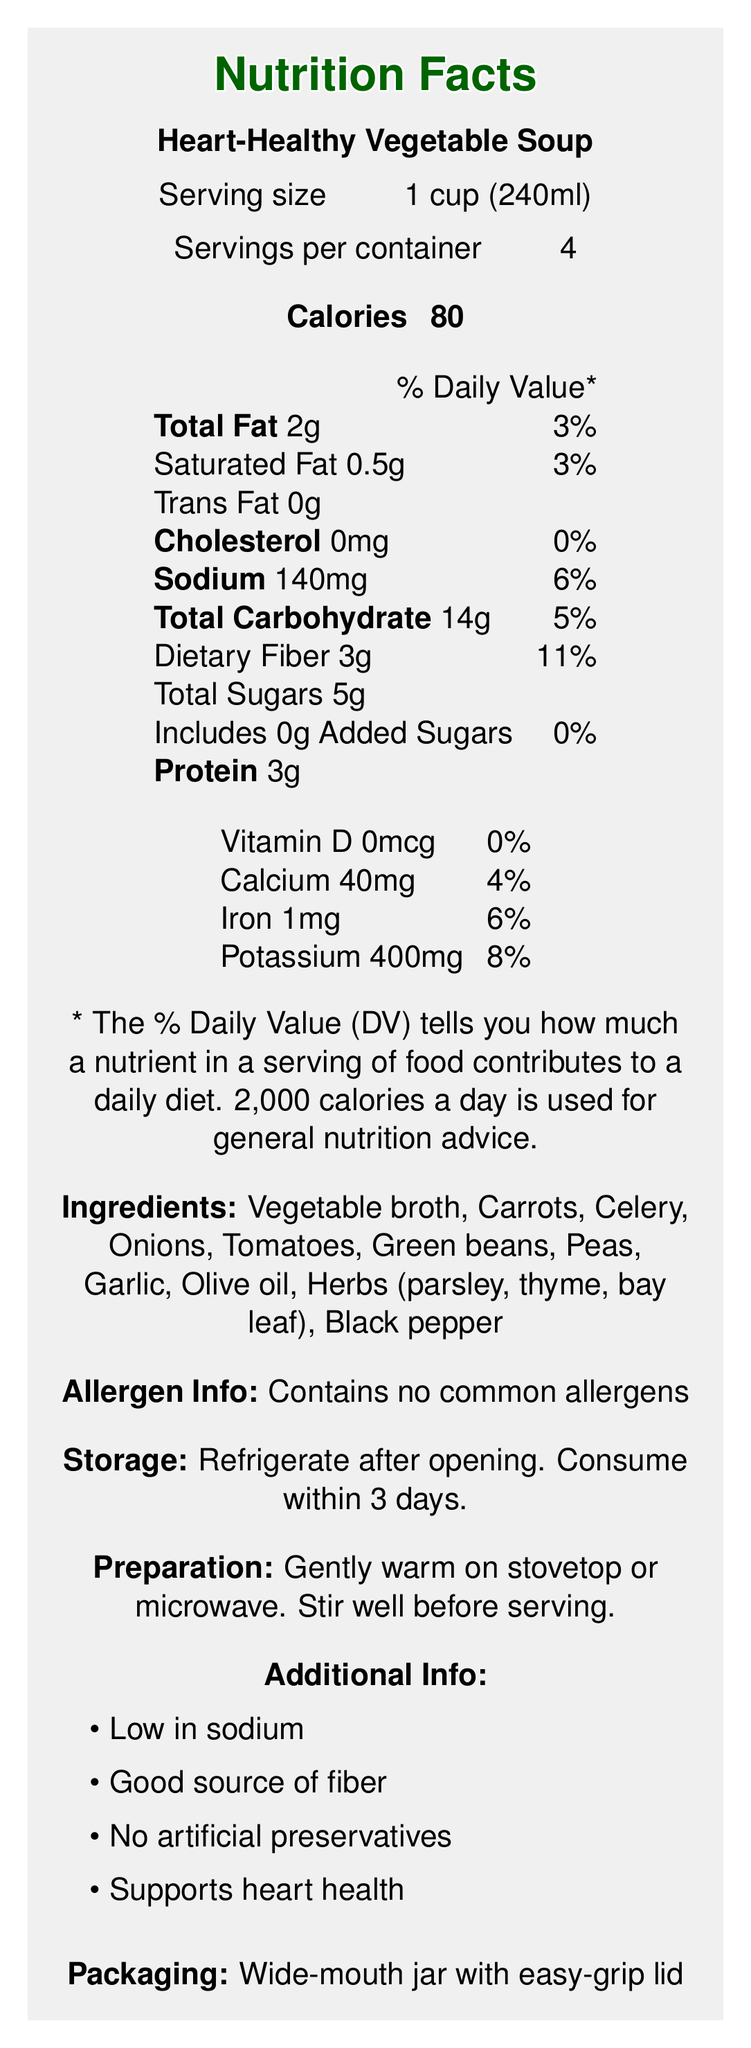what is the product name? The product name is clearly mentioned at the top of the Nutrition Facts Label as "Heart-Healthy Vegetable Soup."
Answer: Heart-Healthy Vegetable Soup what is the serving size? The serving size is specified right below the product name, "Serving size 1 cup (240ml)."
Answer: 1 cup (240ml) how many calories are in one serving of this soup? The number of calories per serving is listed as "Calories 80" in the document.
Answer: 80 what percentage of daily value is the sodium content per serving? The % Daily Value for sodium is indicated as "Sodium 140mg 6%" on the label.
Answer: 6% how many grams of dietary fiber are in a serving of this soup? The label specifies "Dietary Fiber 3g" under the total carbohydrate section.
Answer: 3g what vitamins and minerals are listed with their daily values? The vitamins and minerals along with their daily values are listed as "Vitamin D 0mcg 0%, Calcium 40mg 4%, Iron 1mg 6%, Potassium 400mg 8%."
Answer: Vitamin D, Calcium, Iron, Potassium what are the total servings per container? The number of servings per container is specified as "Servings per container 4."
Answer: 4 which ingredients are specified in the soup? A. Chicken broth, Carrots, Celery B. Vegetable broth, Carrots, Celery C. Beef broth, Carrots, Celery The ingredients are described as "Vegetable broth, Carrots, Celery" along with other vegetables and herbs.
Answer: B what is the cholesterol content per serving? The label indicates the cholesterol content as "Cholesterol 0mg 0%" under the fat content section.
Answer: 0mg is this soup a good source of fiber? True or False The document highlights "Good source of fiber" under the additional information section.
Answer: True which additional information is provided? I. Low in sodium II. No artificial preservatives III. Supports digestive health IV. Supports heart health The additional information states "Low in sodium, No artificial preservatives, Supports heart health" but does not mention supports digestive health.
Answer: I, II, IV what type of allergens does this soup contain? The allergen information is clearly mentioned as "Contains no common allergens."
Answer: Contains no common allergens what preparation tips are provided for the soup? The preparation tips are mentioned as "Gently warm on stovetop or microwave. Stir well before serving."
Answer: Gently warm on stovetop or microwave. Stir well before serving. how should the soup be stored after opening? The storage instructions specify "Refrigerate after opening. Consume within 3 days."
Answer: Refrigerate after opening. Consume within 3 days. what is the font size used in the document? The document indicates "font size: 16pt" in the additional information section.
Answer: 16pt summarize the main information provided in this Nutrition Facts Label. The summary captures all essential aspects of the document including nutritional values, ingredients, allergen information, storage, and preparation instructions. It highlights the product's health benefits and key characteristics.
Answer: The label describes the Heart-Healthy Vegetable Soup, indicating it has low calories, low sodium levels, and is a good source of fiber. It provides detailed nutritional information including serving size, servings per container, and nutritional content per serving such as calories, fats, cholesterol, sodium, carbohydrates, dietary fiber, sugars, protein, vitamins, and minerals. The ingredients list includes various vegetables and herbs. It specifies that the product contains no common allergens, should be refrigerated after opening, and consumed within 3 days. The preparation tips, additional health benefits, and packaging details are also noted. how many vegetables are listed in the ingredients? The exact number of vegetables included in the ingredients is not quantified in the document, even though several vegetables are listed by name.
Answer: Cannot be determined 